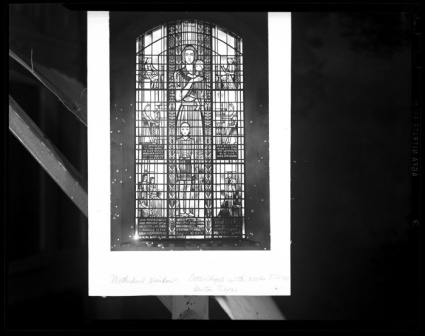Can you describe the main features of this image for me? The image presents a black and white photograph of an ornate stained glass window within a stone-walled setting that suggests a place of worship. The window, displaying Gothic architectural qualities, is composed of many individual glass pieces forming a cohesive and detailed representation of a saint or a venerable religious figure. This central figure appears robed, bearing the likely weight of a sacred text in their hands, perhaps alluding to the gravity of the knowledge within. Modern scaffolding frames the window's exterior, hinting at efforts to preserve or restore the historical edifice it adorns. Notably, the window itself appears to be in pristine condition, standing the test of time, while the photograph exhibits signs of age with visible speckling that could be either dust specks or photo damage, adding a layer of temporal depth to the capture. The image is encased within a dark border, and at the bottom, there's obscured text that implies additional context but is unfortunately illegible. Overall, the photo is not just a static capture, but a temporal bridge connecting the reverence of the past with the care of the present. 